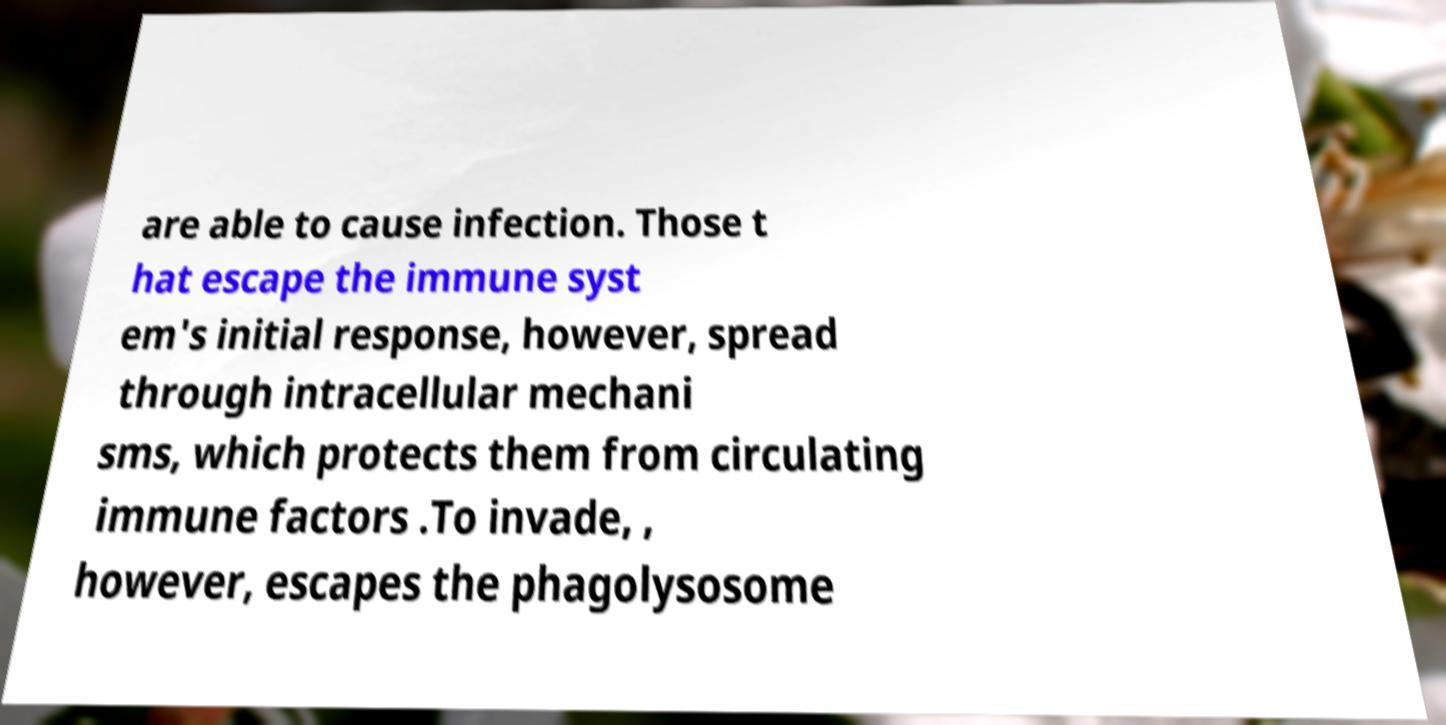Could you assist in decoding the text presented in this image and type it out clearly? are able to cause infection. Those t hat escape the immune syst em's initial response, however, spread through intracellular mechani sms, which protects them from circulating immune factors .To invade, , however, escapes the phagolysosome 